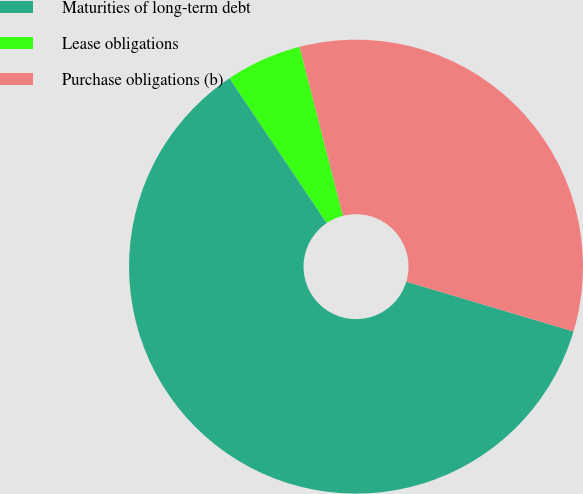<chart> <loc_0><loc_0><loc_500><loc_500><pie_chart><fcel>Maturities of long-term debt<fcel>Lease obligations<fcel>Purchase obligations (b)<nl><fcel>60.98%<fcel>5.41%<fcel>33.61%<nl></chart> 